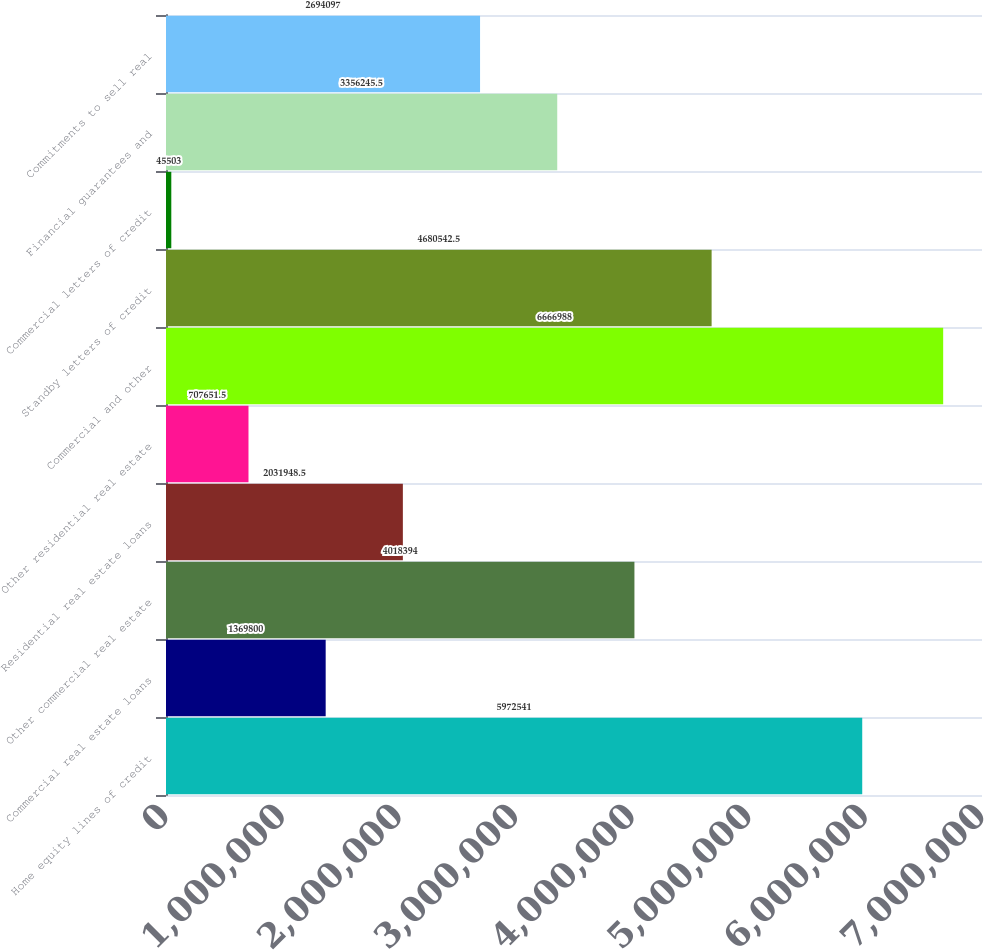Convert chart. <chart><loc_0><loc_0><loc_500><loc_500><bar_chart><fcel>Home equity lines of credit<fcel>Commercial real estate loans<fcel>Other commercial real estate<fcel>Residential real estate loans<fcel>Other residential real estate<fcel>Commercial and other<fcel>Standby letters of credit<fcel>Commercial letters of credit<fcel>Financial guarantees and<fcel>Commitments to sell real<nl><fcel>5.97254e+06<fcel>1.3698e+06<fcel>4.01839e+06<fcel>2.03195e+06<fcel>707652<fcel>6.66699e+06<fcel>4.68054e+06<fcel>45503<fcel>3.35625e+06<fcel>2.6941e+06<nl></chart> 